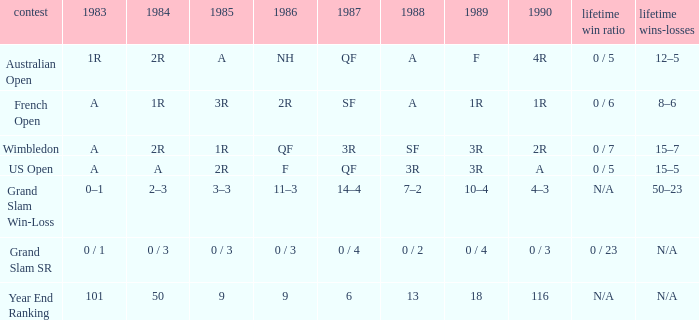In 1983 what is the tournament that is 0 / 1? Grand Slam SR. 